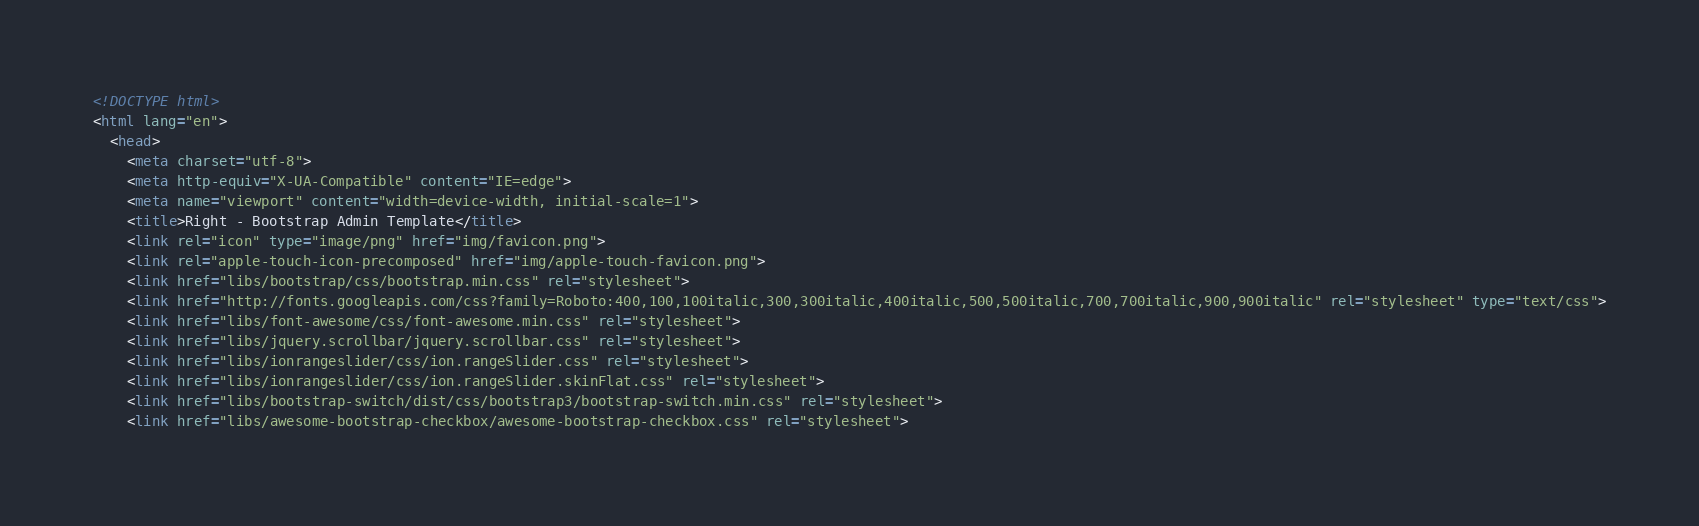<code> <loc_0><loc_0><loc_500><loc_500><_HTML_><!DOCTYPE html>
<html lang="en">
  <head>
    <meta charset="utf-8">
    <meta http-equiv="X-UA-Compatible" content="IE=edge">
    <meta name="viewport" content="width=device-width, initial-scale=1">
    <title>Right - Bootstrap Admin Template</title>
    <link rel="icon" type="image/png" href="img/favicon.png">
    <link rel="apple-touch-icon-precomposed" href="img/apple-touch-favicon.png">
    <link href="libs/bootstrap/css/bootstrap.min.css" rel="stylesheet">
    <link href="http://fonts.googleapis.com/css?family=Roboto:400,100,100italic,300,300italic,400italic,500,500italic,700,700italic,900,900italic" rel="stylesheet" type="text/css">
    <link href="libs/font-awesome/css/font-awesome.min.css" rel="stylesheet">
    <link href="libs/jquery.scrollbar/jquery.scrollbar.css" rel="stylesheet">
    <link href="libs/ionrangeslider/css/ion.rangeSlider.css" rel="stylesheet">
    <link href="libs/ionrangeslider/css/ion.rangeSlider.skinFlat.css" rel="stylesheet">
    <link href="libs/bootstrap-switch/dist/css/bootstrap3/bootstrap-switch.min.css" rel="stylesheet">
    <link href="libs/awesome-bootstrap-checkbox/awesome-bootstrap-checkbox.css" rel="stylesheet"></code> 